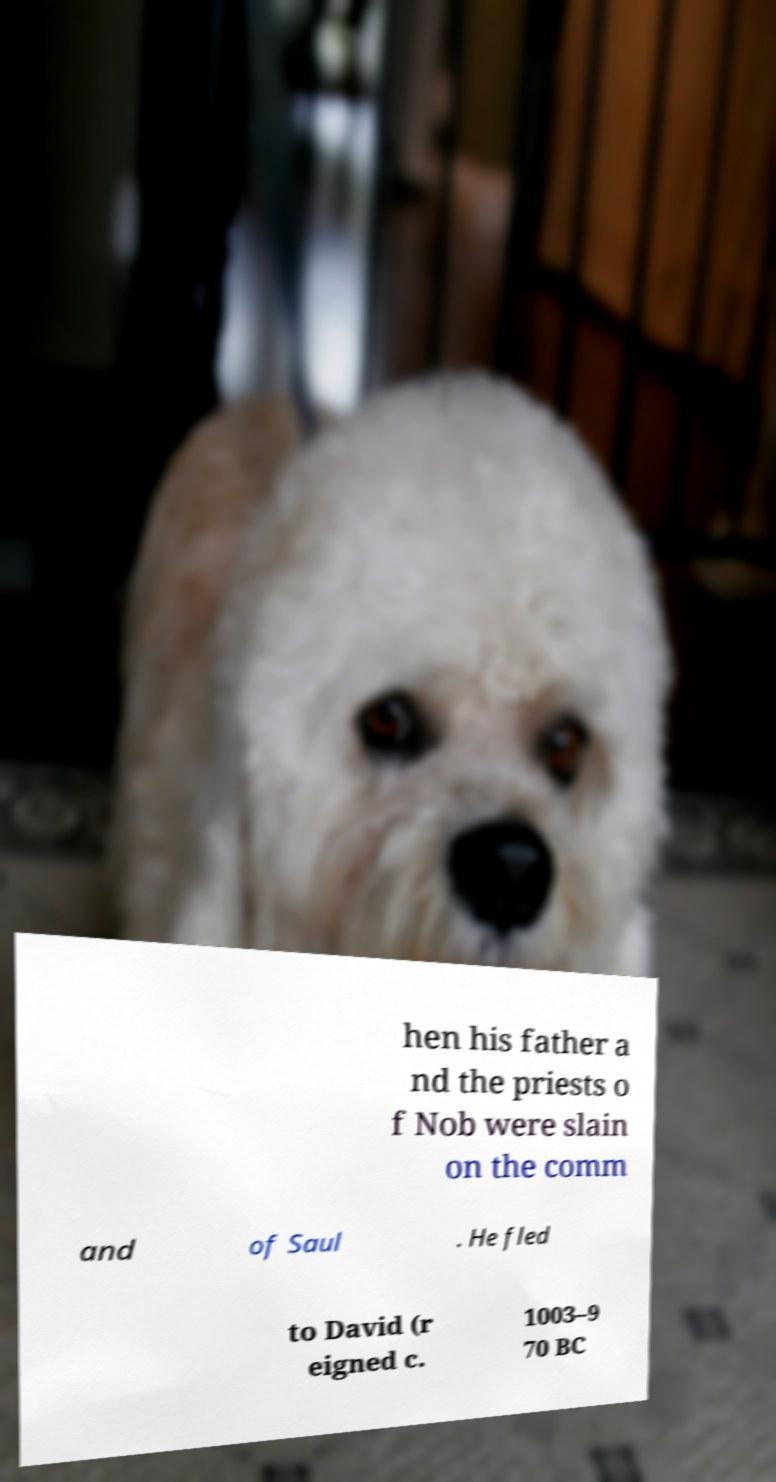Could you assist in decoding the text presented in this image and type it out clearly? hen his father a nd the priests o f Nob were slain on the comm and of Saul . He fled to David (r eigned c. 1003–9 70 BC 